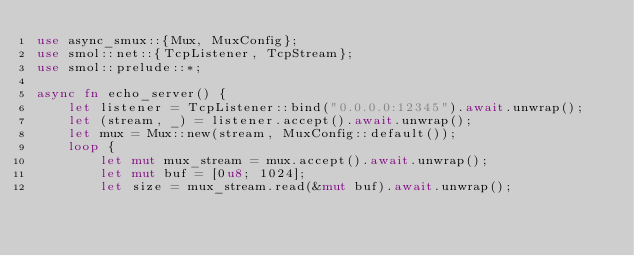<code> <loc_0><loc_0><loc_500><loc_500><_Rust_>use async_smux::{Mux, MuxConfig};
use smol::net::{TcpListener, TcpStream};
use smol::prelude::*;

async fn echo_server() {
    let listener = TcpListener::bind("0.0.0.0:12345").await.unwrap();
    let (stream, _) = listener.accept().await.unwrap();
    let mux = Mux::new(stream, MuxConfig::default());
    loop {
        let mut mux_stream = mux.accept().await.unwrap();
        let mut buf = [0u8; 1024];
        let size = mux_stream.read(&mut buf).await.unwrap();</code> 